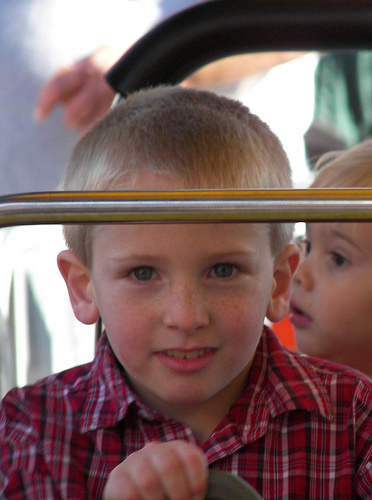<image>
Can you confirm if the boy is behind the bar? Yes. From this viewpoint, the boy is positioned behind the bar, with the bar partially or fully occluding the boy. Is there a boy next to the boy? Yes. The boy is positioned adjacent to the boy, located nearby in the same general area. 